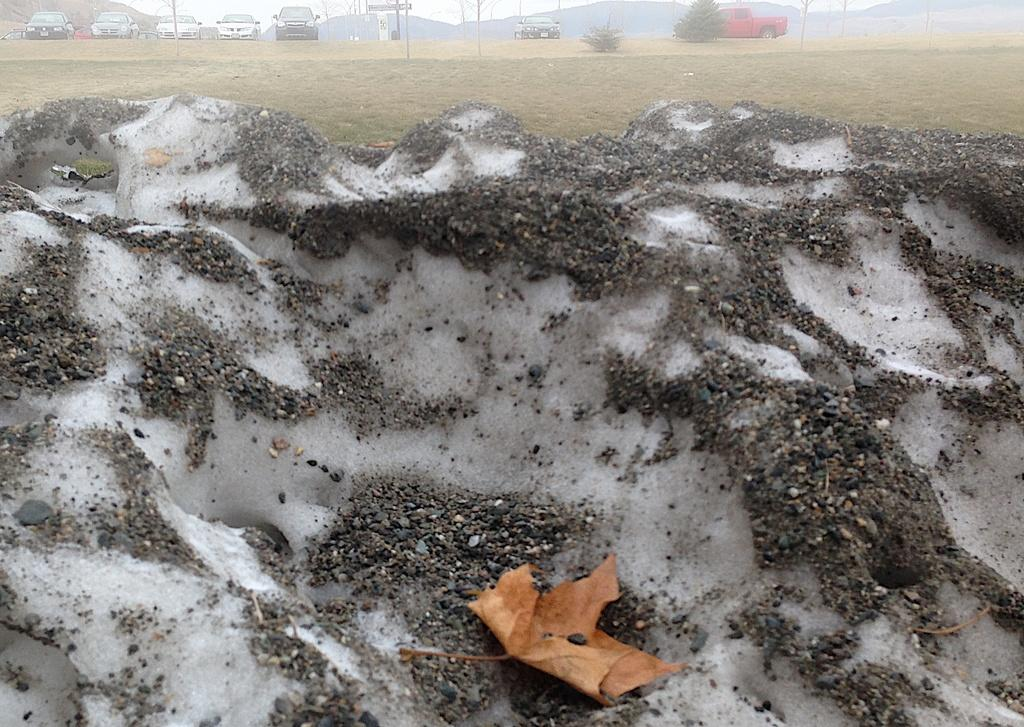What type of terrain is depicted in the image? There is sand and grass on the ground in the image. What vehicles can be seen in the image? Cars are visible in the image. How does the wealth of the people in the image affect the quality of the tent they are using? There is no tent present in the image, and therefore no indication of the wealth of the people or the quality of any tent. 